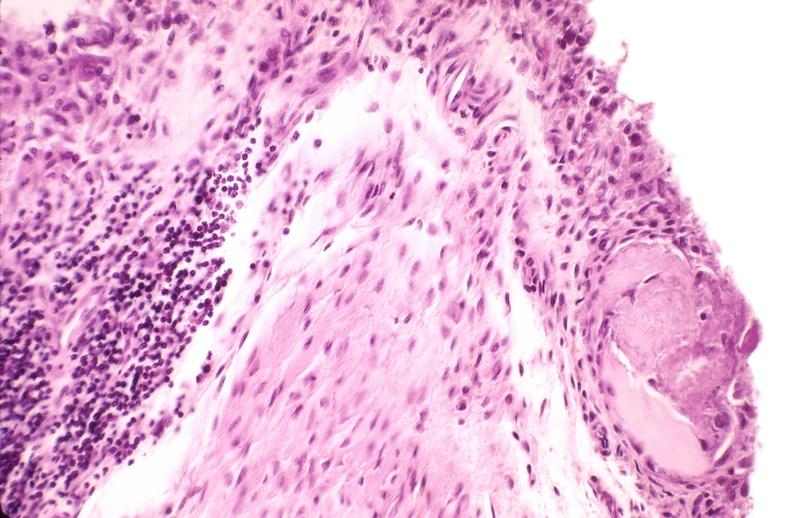does krukenberg tumor show rheumatoid arthritis, synovial hypertrophy with formation of villi pannus?
Answer the question using a single word or phrase. No 